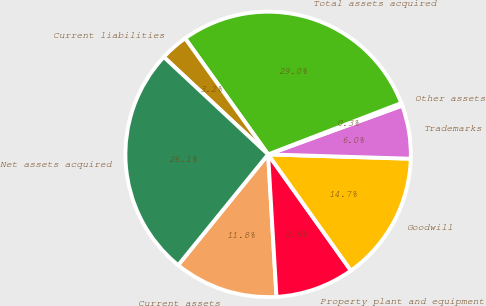Convert chart to OTSL. <chart><loc_0><loc_0><loc_500><loc_500><pie_chart><fcel>Current assets<fcel>Property plant and equipment<fcel>Goodwill<fcel>Trademarks<fcel>Other assets<fcel>Total assets acquired<fcel>Current liabilities<fcel>Net assets acquired<nl><fcel>11.79%<fcel>8.92%<fcel>14.66%<fcel>6.04%<fcel>0.3%<fcel>29.02%<fcel>3.17%<fcel>26.1%<nl></chart> 